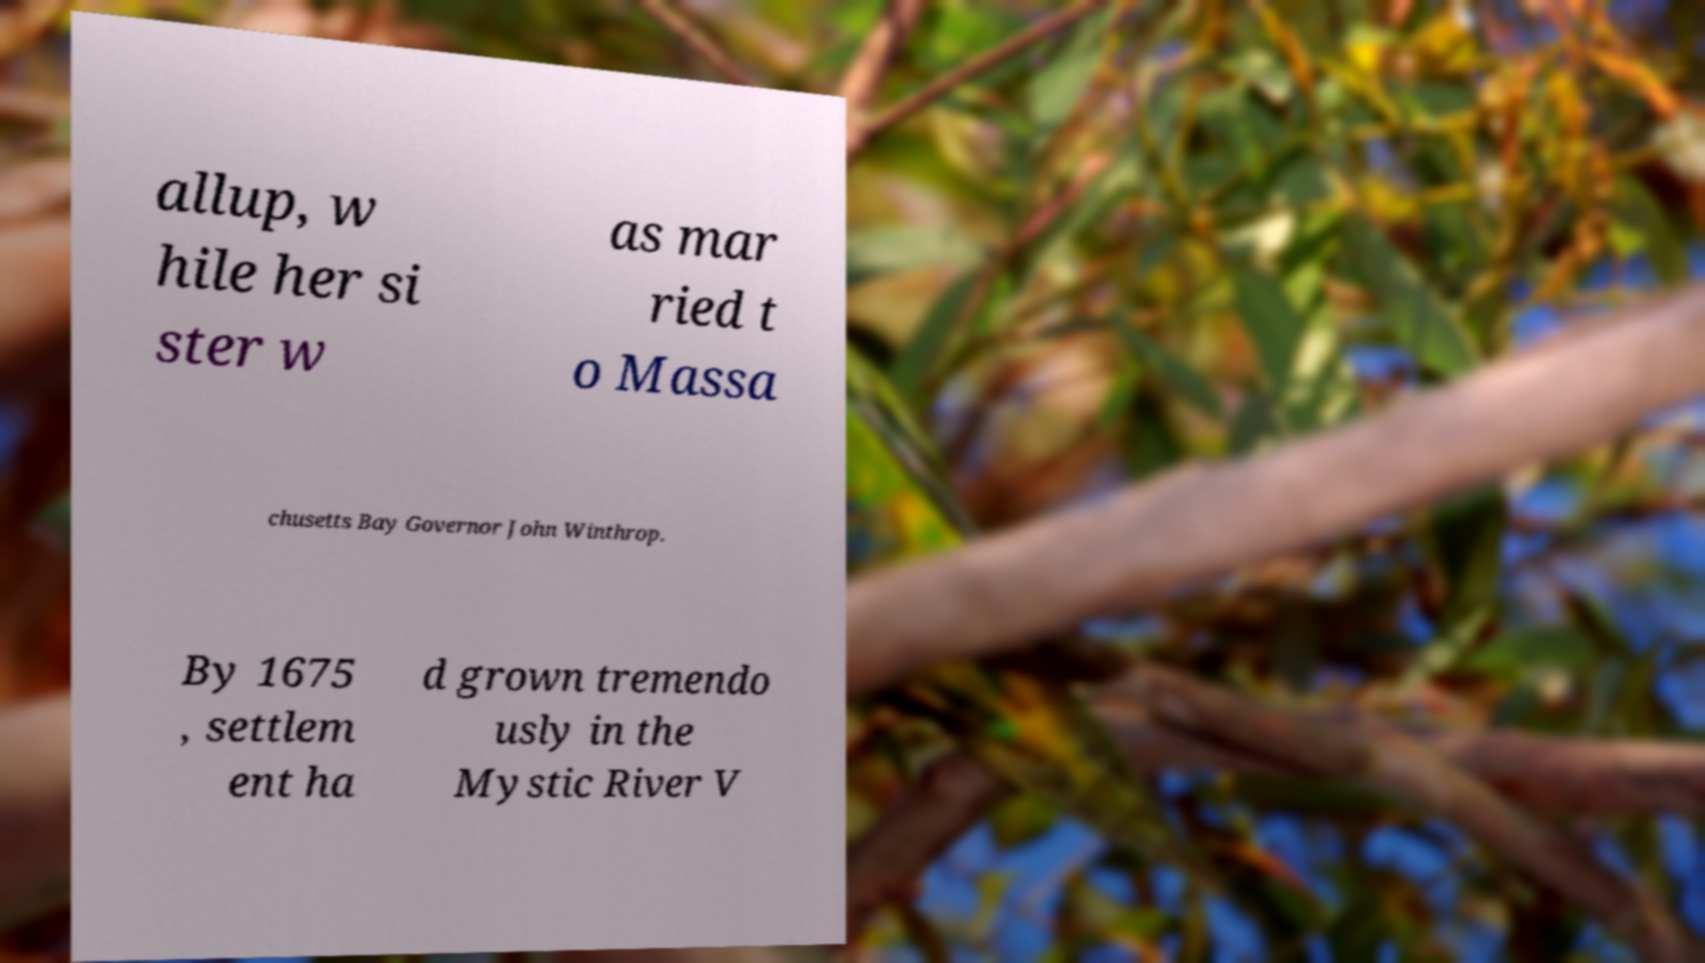Please identify and transcribe the text found in this image. allup, w hile her si ster w as mar ried t o Massa chusetts Bay Governor John Winthrop. By 1675 , settlem ent ha d grown tremendo usly in the Mystic River V 